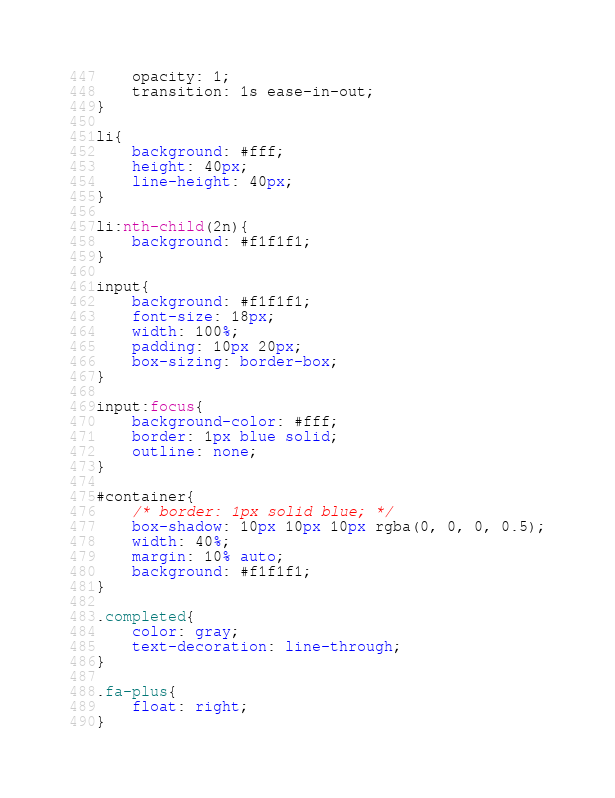Convert code to text. <code><loc_0><loc_0><loc_500><loc_500><_CSS_>    opacity: 1;
    transition: 1s ease-in-out;
}

li{
    background: #fff;
    height: 40px;
    line-height: 40px;
}

li:nth-child(2n){
    background: #f1f1f1;
}

input{
    background: #f1f1f1;
    font-size: 18px;
    width: 100%;
    padding: 10px 20px;
    box-sizing: border-box;
}

input:focus{
    background-color: #fff;
    border: 1px blue solid;
    outline: none;
}

#container{
    /* border: 1px solid blue; */
    box-shadow: 10px 10px 10px rgba(0, 0, 0, 0.5);
    width: 40%;
    margin: 10% auto;
    background: #f1f1f1;
}

.completed{
    color: gray;
    text-decoration: line-through;
}

.fa-plus{
    float: right;
}

</code> 